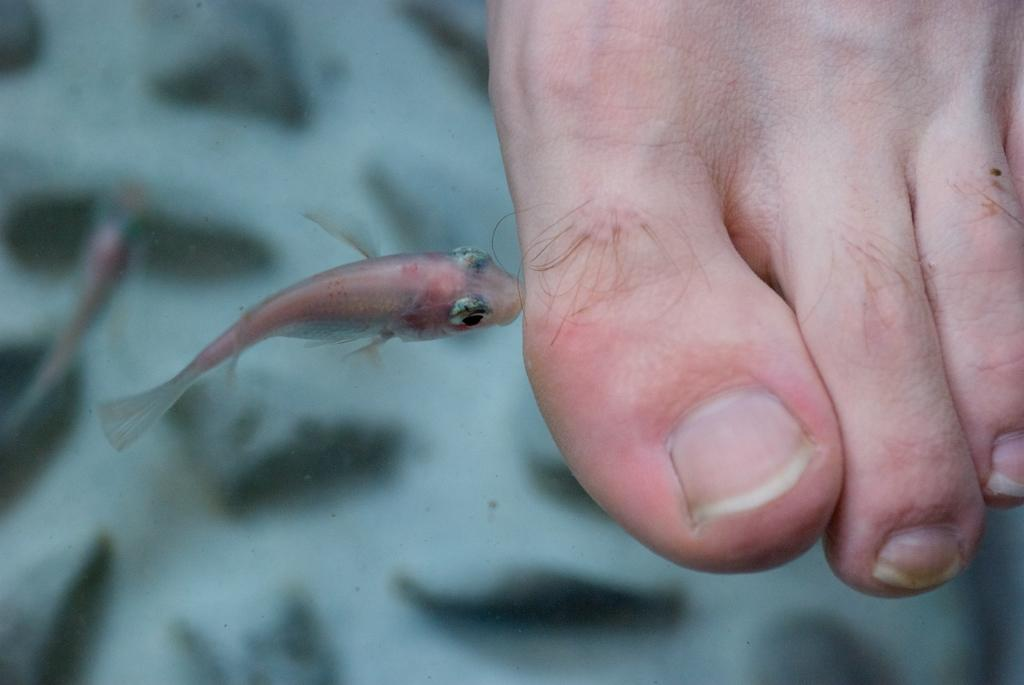What animals are on the left side of the image? There are two fishes on the left side of the image. What body part is on the right side of the image? There is a human leg on the right side of the image. What type of ear can be seen on the fishes in the image? There are no ears visible on the fishes in the image, as they are aquatic animals and do not have ears like humans. 